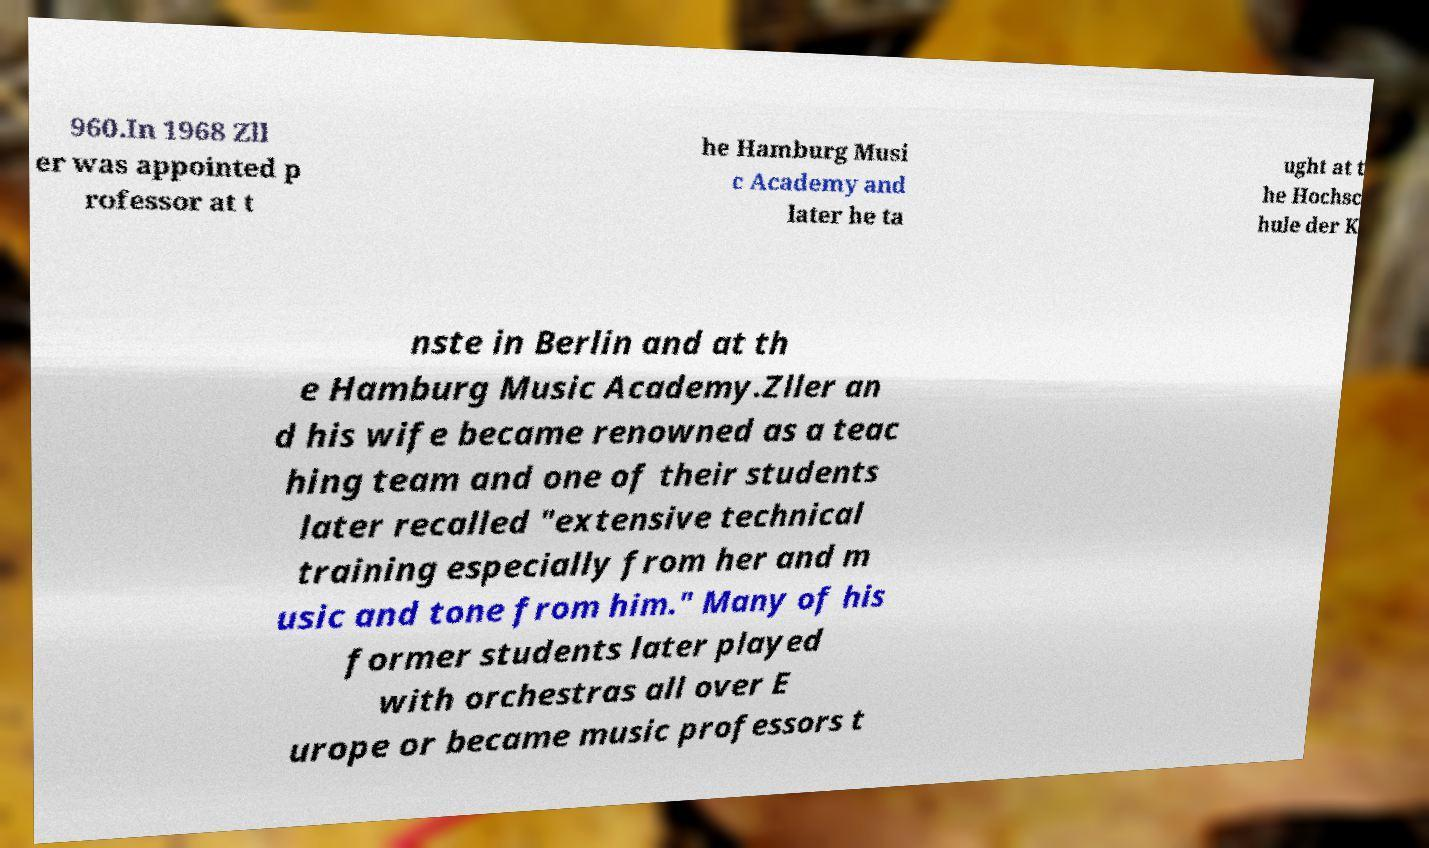Could you assist in decoding the text presented in this image and type it out clearly? 960.In 1968 Zll er was appointed p rofessor at t he Hamburg Musi c Academy and later he ta ught at t he Hochsc hule der K nste in Berlin and at th e Hamburg Music Academy.Zller an d his wife became renowned as a teac hing team and one of their students later recalled "extensive technical training especially from her and m usic and tone from him." Many of his former students later played with orchestras all over E urope or became music professors t 